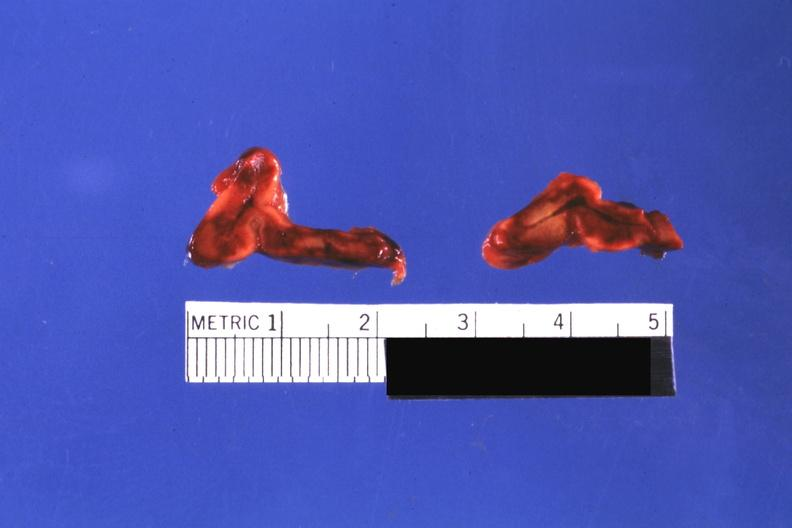what does cut surfaces of both adrenals focal hemorrhagic infarction well shown do not know history look?
Answer the question using a single word or phrase. Like placental abruption 